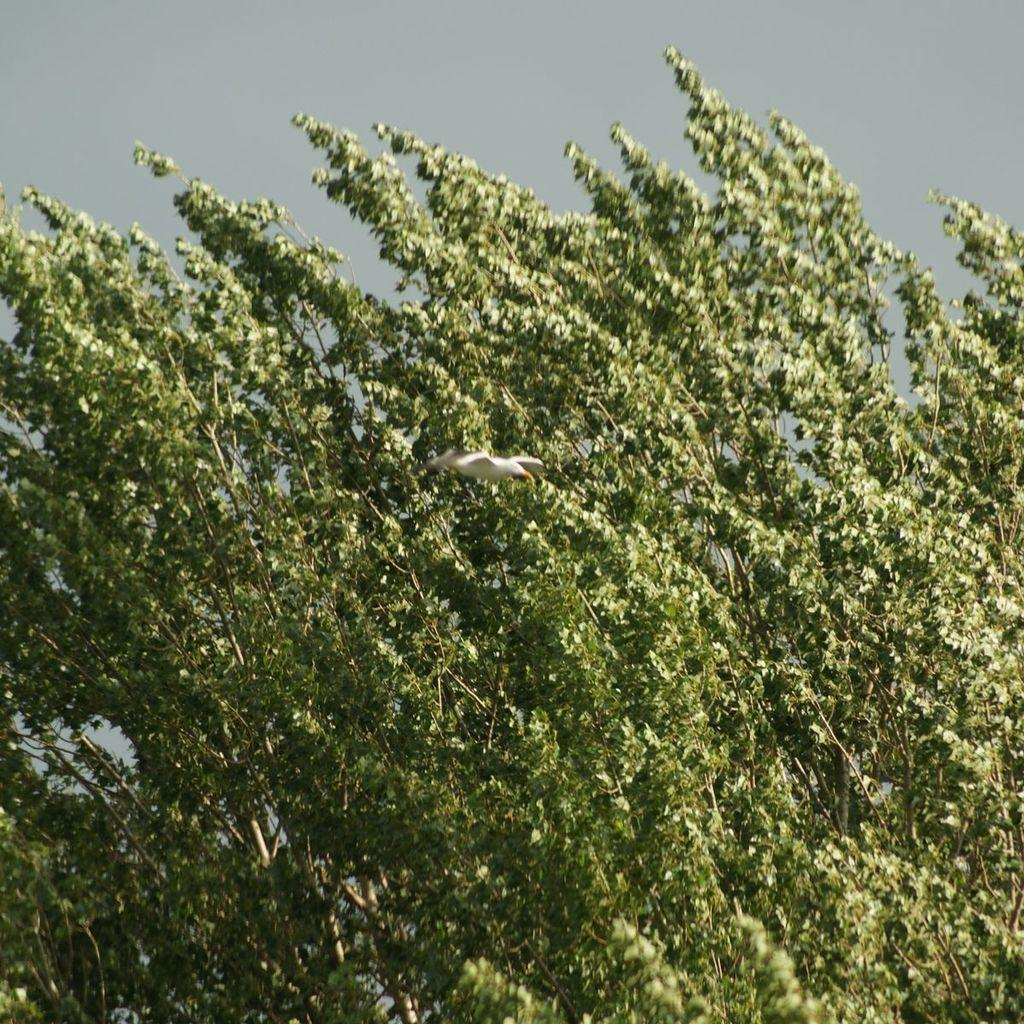What type of plant can be seen in the image? There is a tree in the image. What is the bird in the image doing? A bird is flying in the air in the image. What is visible at the top of the image? The sky is visible at the top of the image. What type of yarn is being used to create the comparison between the bedroom and the tree in the image? There is no yarn or comparison between a bedroom and the tree in the image. 